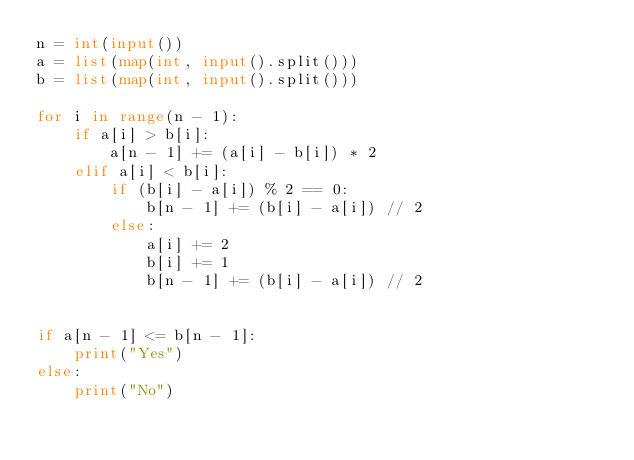Convert code to text. <code><loc_0><loc_0><loc_500><loc_500><_Python_>n = int(input())
a = list(map(int, input().split()))
b = list(map(int, input().split()))

for i in range(n - 1):
    if a[i] > b[i]:
        a[n - 1] += (a[i] - b[i]) * 2
    elif a[i] < b[i]:
        if (b[i] - a[i]) % 2 == 0:
            b[n - 1] += (b[i] - a[i]) // 2
        else:
            a[i] += 2
            b[i] += 1
            b[n - 1] += (b[i] - a[i]) // 2


if a[n - 1] <= b[n - 1]:
    print("Yes")
else:
    print("No")</code> 